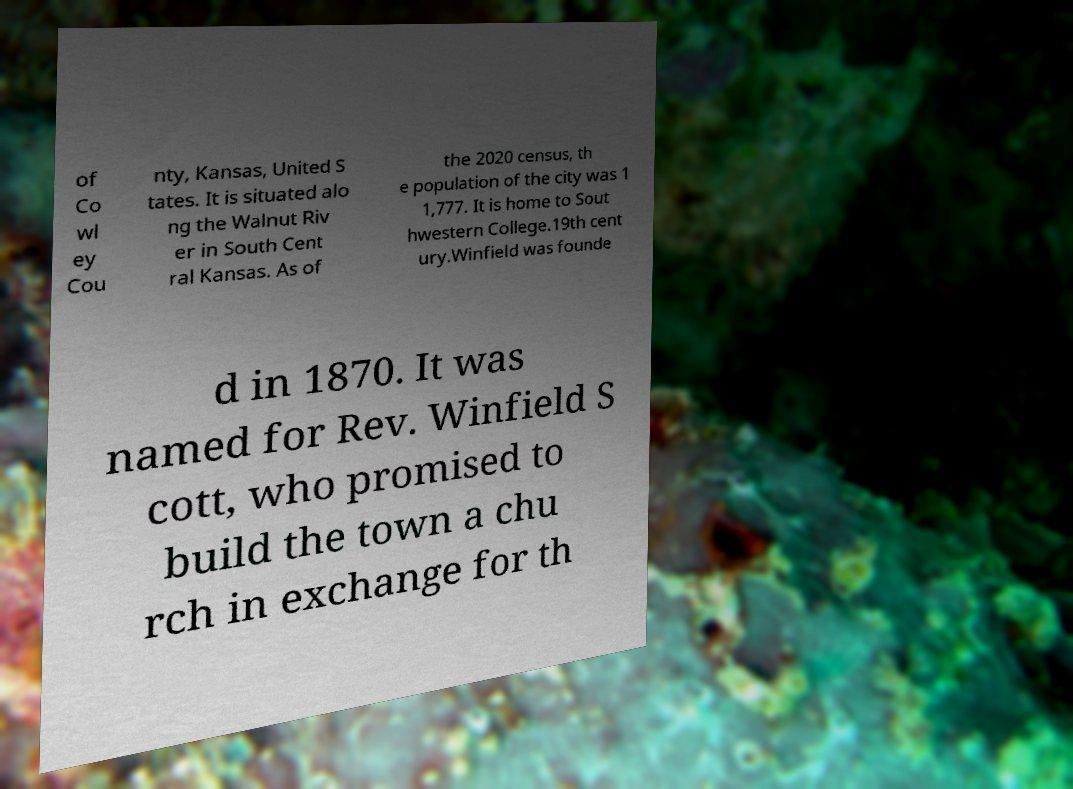Please identify and transcribe the text found in this image. of Co wl ey Cou nty, Kansas, United S tates. It is situated alo ng the Walnut Riv er in South Cent ral Kansas. As of the 2020 census, th e population of the city was 1 1,777. It is home to Sout hwestern College.19th cent ury.Winfield was founde d in 1870. It was named for Rev. Winfield S cott, who promised to build the town a chu rch in exchange for th 